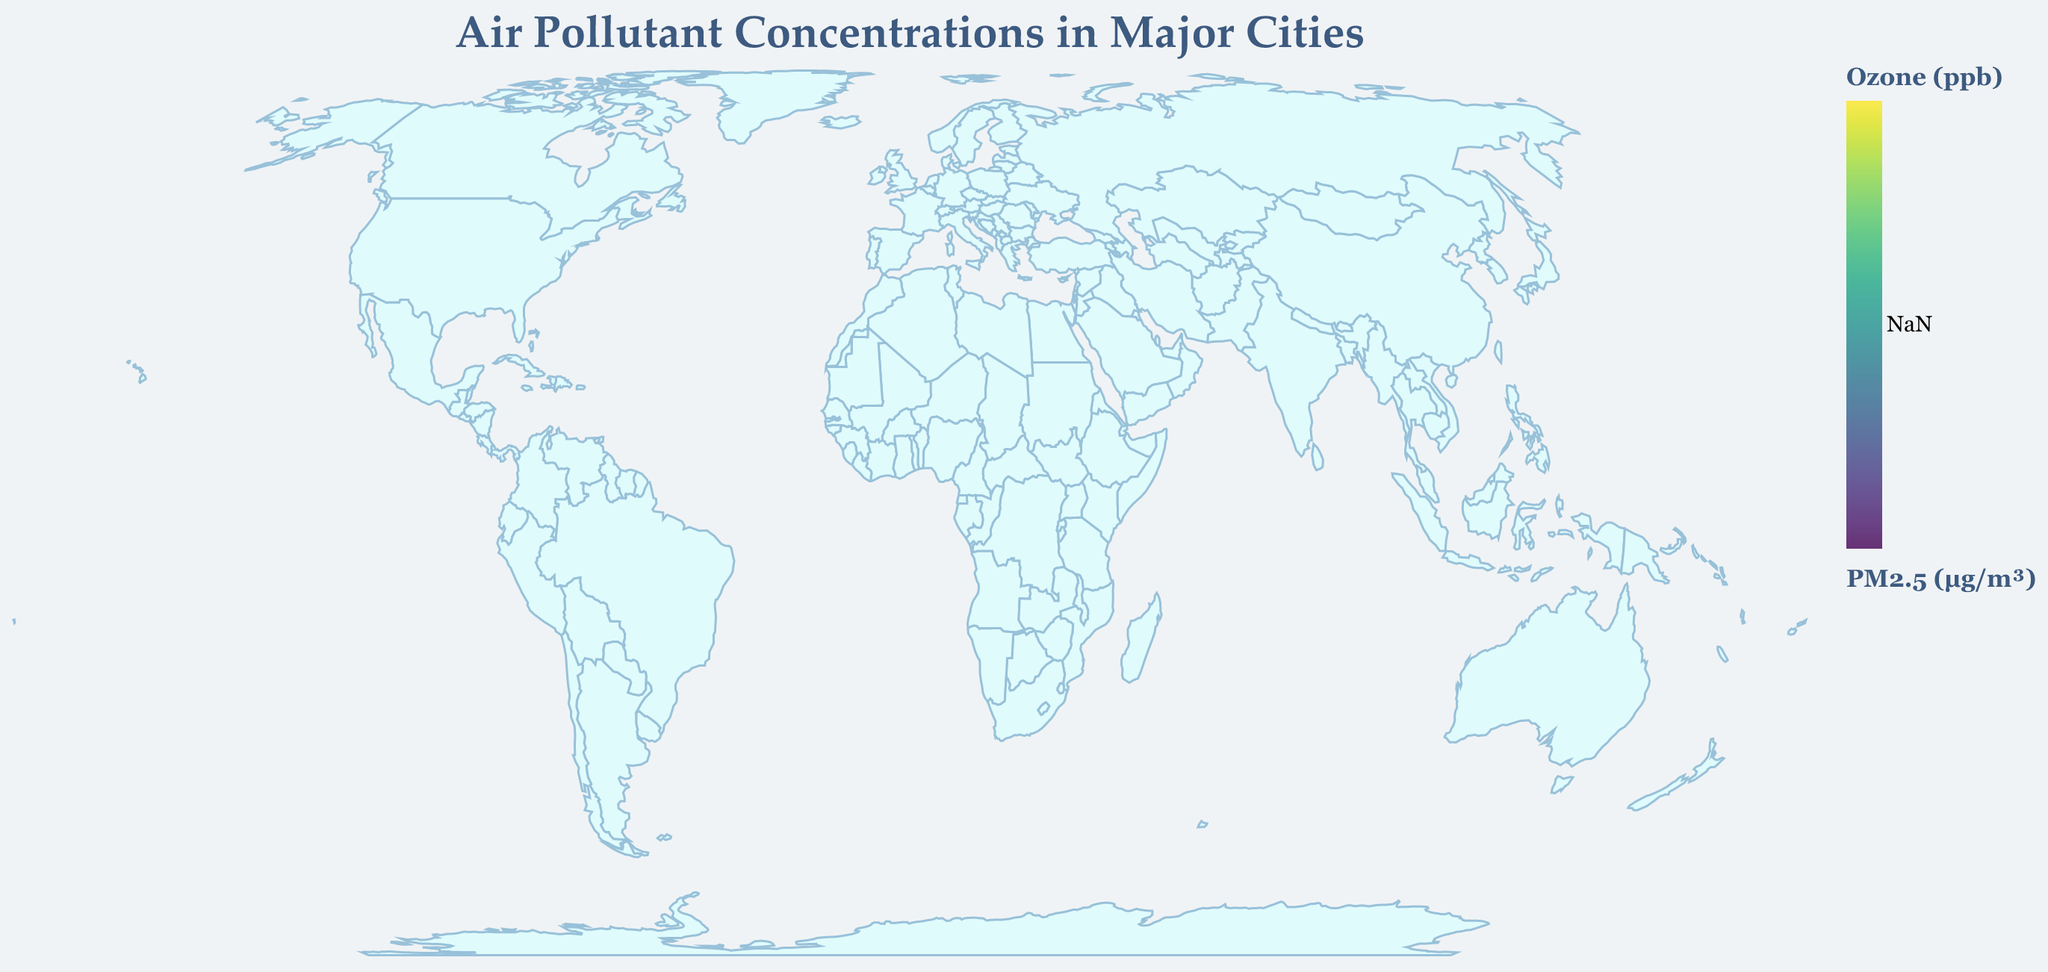What's the title of the figure? The title of the figure is located at the top of the plot and reads "Air Pollutant Concentrations in Major Cities" in a larger font size.
Answer: Air Pollutant Concentrations in Major Cities Which city has the highest Ozone concentration? New Delhi, displayed in deeper color tones in the legend, has the highest Ozone concentration of 52 ppb.
Answer: New Delhi Which city has the lowest PM2.5 concentration? The smallest circle size indicates the lowest PM2.5 of 8 µg/m³, which belongs to Sydney.
Answer: Sydney What are the NO2 levels in Cairo? Locating Cairo on the map tooltip reveals date, which shows NO2 concentration is 64 ppb.
Answer: 64 ppb Which city has higher PM2.5: Mexico City or Paris? By comparing the circle sizes of Mexico City (21 µg/m³) and Paris (15 µg/m³), Mexico City has a higher PM2.5 concentration.
Answer: Mexico City Which city exhibits both high PM2.5 and high NO2 levels? New Delhi exhibits the largest PM2.5 (98 µg/m³) and high NO2 (53 ppb) levels by identifing both a large circle size and tooltip content.
Answer: New Delhi How does the Ozone concentration in Los Angeles compare to Sydney? By observing the color differences, Los Angeles has a deeper hue (49 ppb) compared to Sydney (28 ppb).
Answer: Los Angeles > Sydney What's the average PM2.5 value for the cities in the dataset? Summing the PM2.5 values and dividing by the number of cities: (58 + 14 + 11 + 98 + 21 + 73 + 13 + 15 + 18 + 8) / 10 = 32.9 µg/m³.
Answer: 32.9 µg/m³ Which city is located closest to the equator with high air pollutants? São Paulo is located at -23.5505 latitude and shows high air pollutants levels (PM2.5: 18 µg/m³, Ozone: 35 ppb, NO2: 33 ppb).
Answer: São Paulo How do PM2.5 and Ozone levels in Tokyo compare? Tokyo shows PM2.5 concentration of 13 µg/m³ with a corresponding lighter circle size and lower Ozone level of 27 ppb visible in tooltip.
Answer: PM2.5: 13 µg/m³, Ozone: 27 ppb 